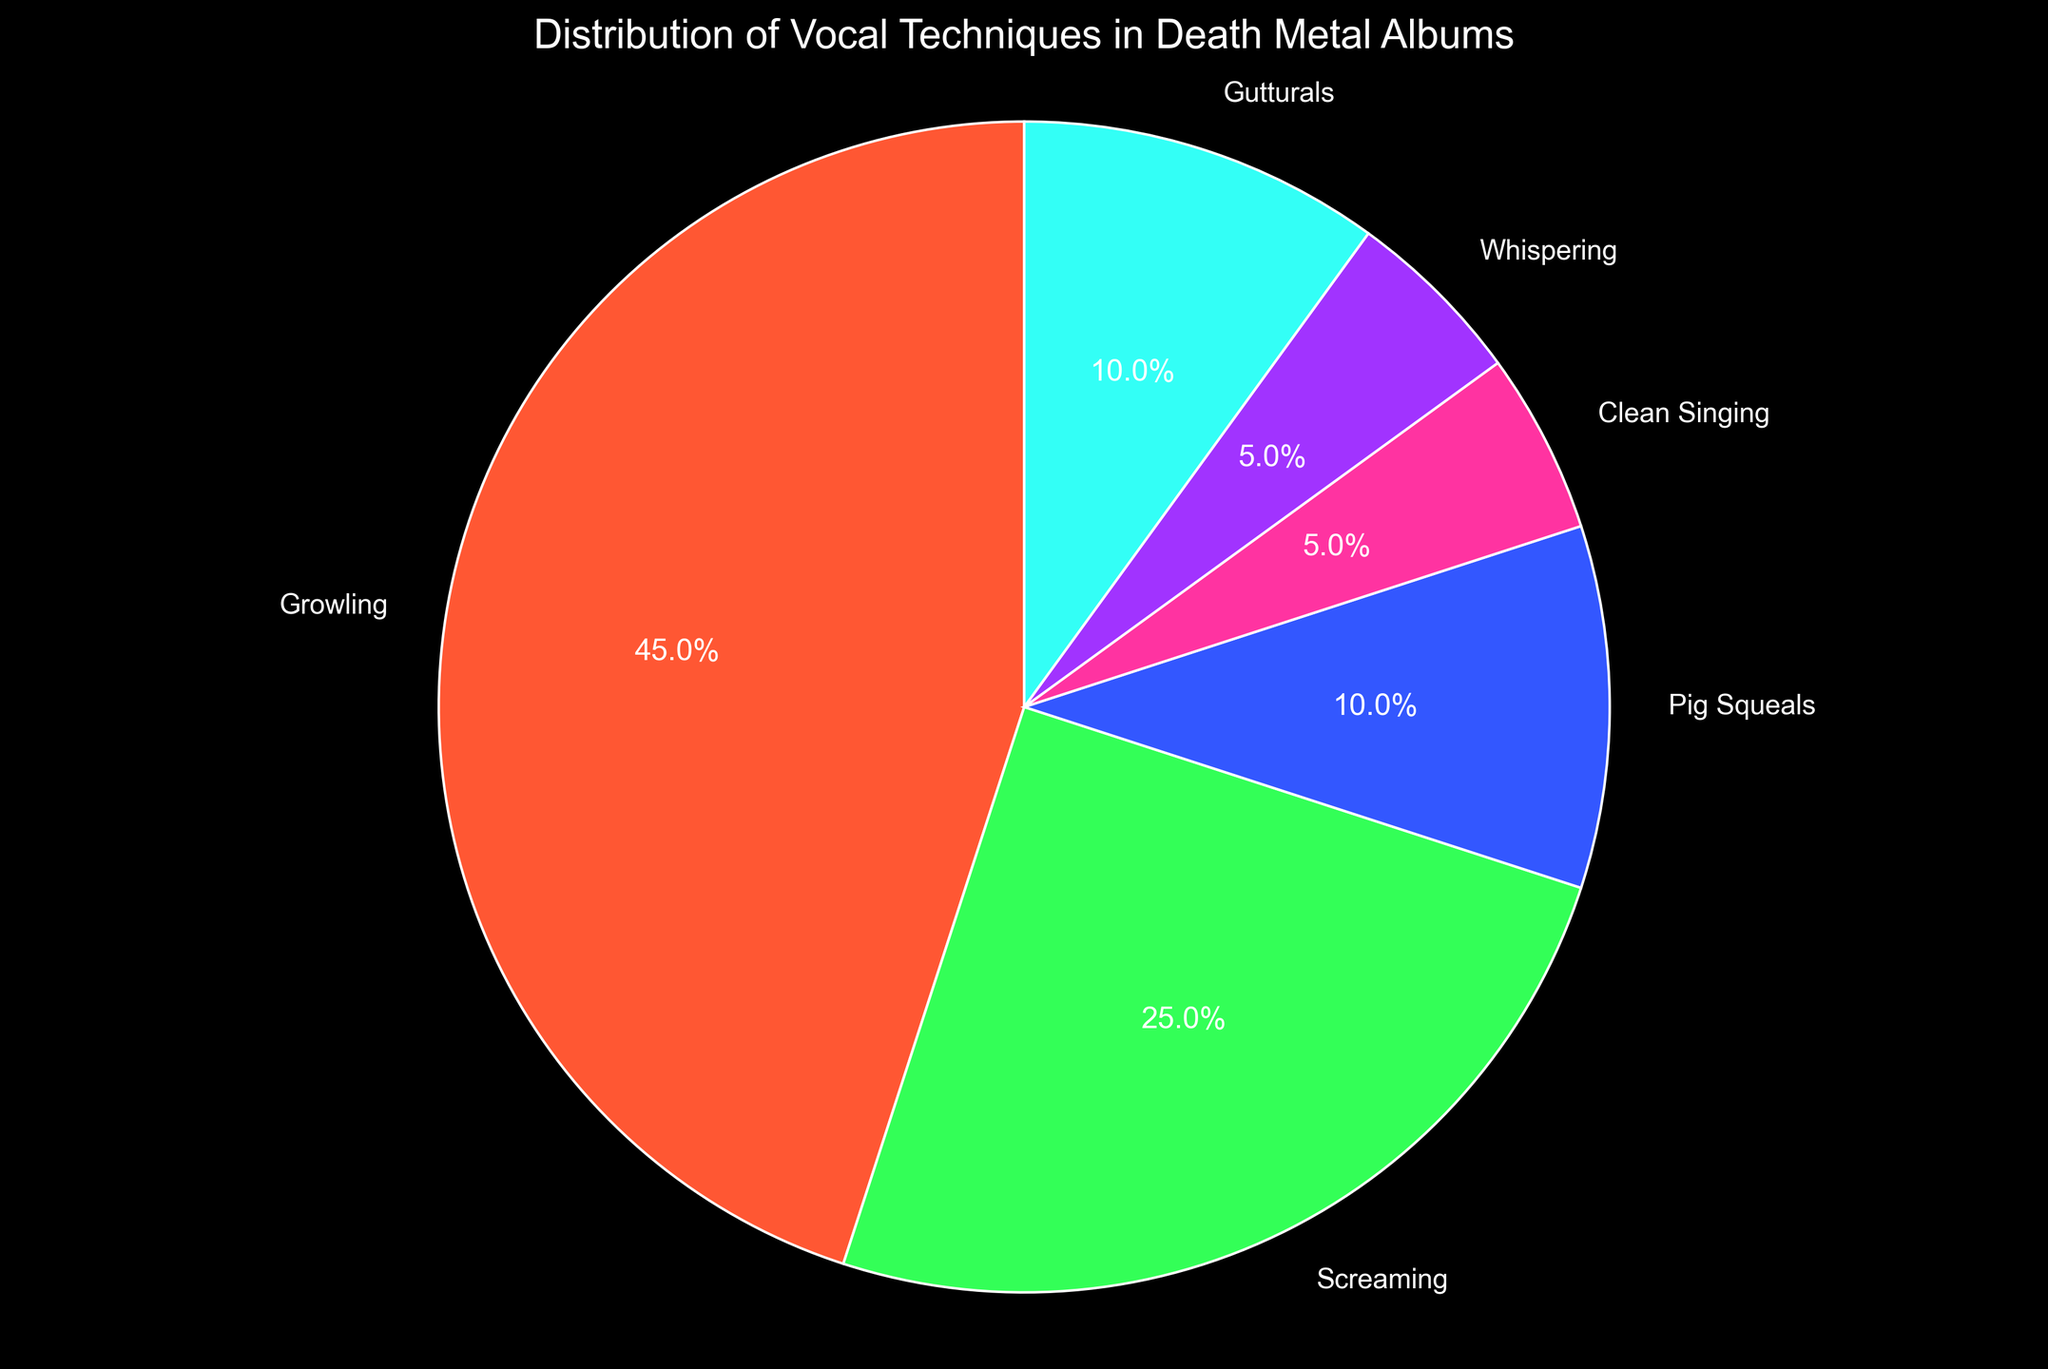What percentage of vocal techniques used in death metal albums is attributed to Growling and Screaming combined? To find the combined percentage of Growling and Screaming, simply add their individual percentages. Growling is 45% and Screaming is 25%. Hence, the combined percentage is 45 + 25 = 70%.
Answer: 70% Which vocal technique has the lowest percentage usage, and what is that percentage? By looking at the pie chart, we see that both Clean Singing and Whispering each occupy the smallest sections, both labeled as 5%.
Answer: Clean Singing and Whispering, 5% Is the percentage usage of Pig Squeals greater than the combined percentage of Clean Singing and Whispering? To determine this, first find the sum of the percentages for Clean Singing and Whispering. Clean Singing is 5% and Whispering is 5%, which makes 5 + 5 = 10%. Pig Squeals is also 10%, so the percentage usage is equal, not greater.
Answer: No, equal at 10% What is the sum of the percentages for the techniques used less than 10%? Techniques used less than 10% include Clean Singing (5%) and Whispering (5%). Adding these percentages: 5 + 5 = 10%.
Answer: 10% How does the percentage of Gutturals compare to that of Screaming? Comparing the two percentages directly, Gutturals are 10% while Screaming is 25%. Thus, Screaming has a higher percentage usage than Gutturals.
Answer: Screaming is higher What fraction of the pie chart is taken up by Clean Singing and Whispering together? Clean Singing and Whispering each have 5%, and together they make up 5 + 5 = 10%. The fraction they occupy in the pie chart is therefore 10/100, which simplifies to 1/10.
Answer: 1/10 If the percentage usage of Growling increased by 5%, what would be its new percentage and would it then exceed 50% of the total techniques? Increasing Growling by 5% brings it from 45% to 45 + 5 = 50%. This new percentage would precisely constitute 50% of the total techniques.
Answer: 50%, equal to 50% What is the difference in percentage between the most and least used vocal techniques? The most used vocal technique is Growling at 45%, and the least used techniques are both Clean Singing and Whispering at 5%. The difference is 45 - 5 = 40%.
Answer: 40% Which vocal technique is represented with the color green in the pie chart? By observing the pie chart with labeled sections and colors, Screaming is represented by the color green.
Answer: Screaming 